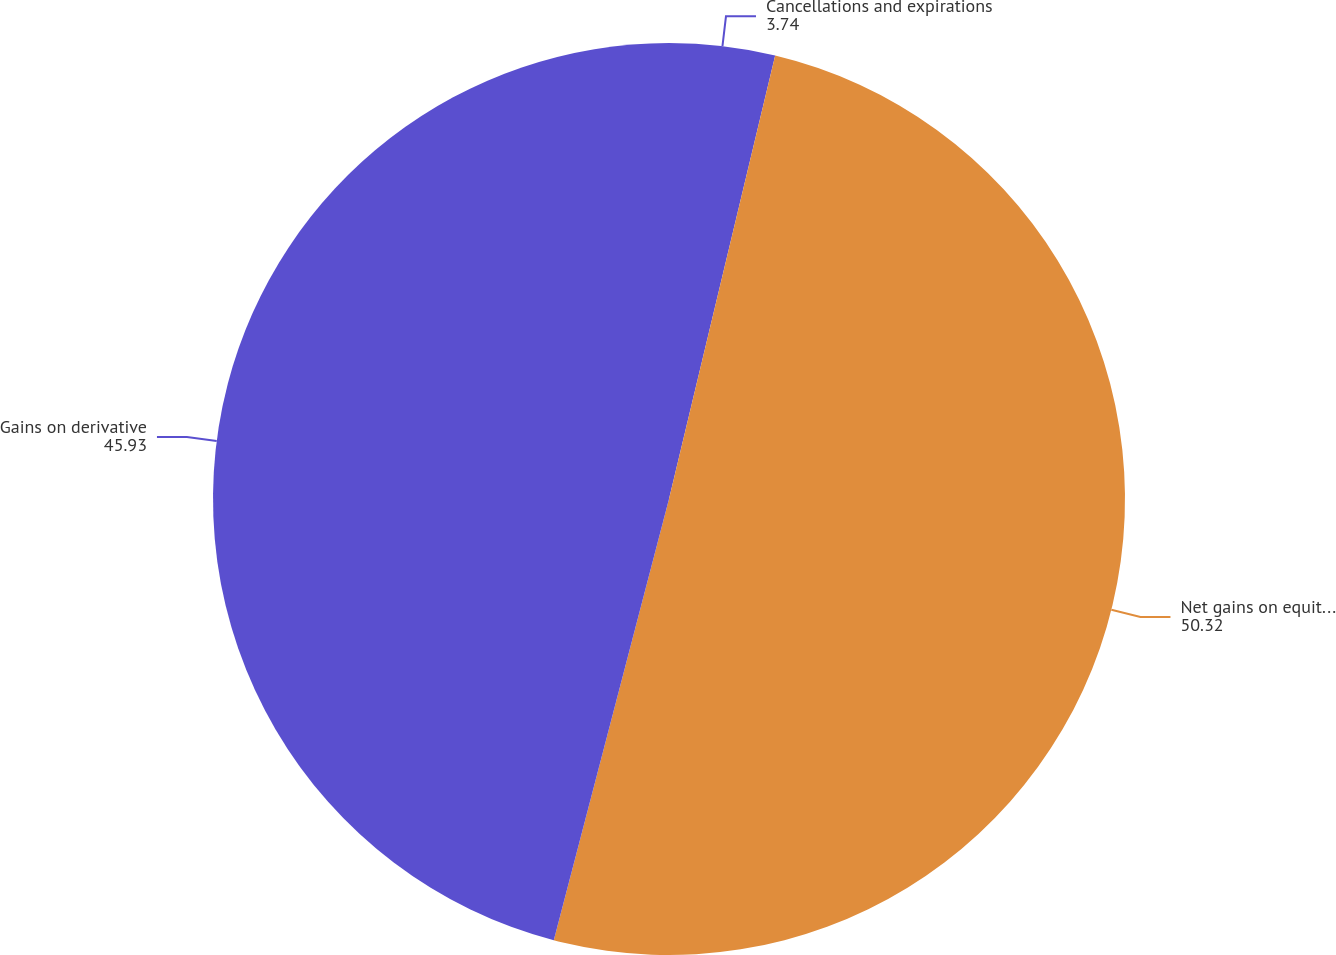Convert chart to OTSL. <chart><loc_0><loc_0><loc_500><loc_500><pie_chart><fcel>Cancellations and expirations<fcel>Net gains on equity warrant<fcel>Gains on derivative<nl><fcel>3.74%<fcel>50.32%<fcel>45.93%<nl></chart> 